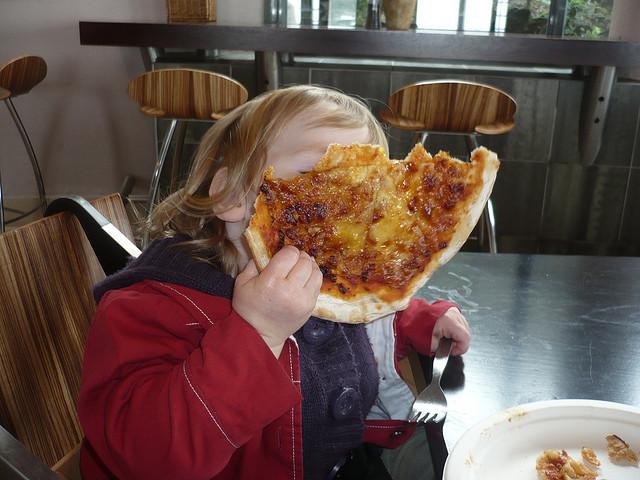What utensil is the child holding?
Give a very brief answer. Fork. What is covering the child's face?
Short answer required. Pizza. Is the child a boy or a girl?
Answer briefly. Girl. 